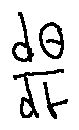<formula> <loc_0><loc_0><loc_500><loc_500>\frac { d \theta } { d t }</formula> 